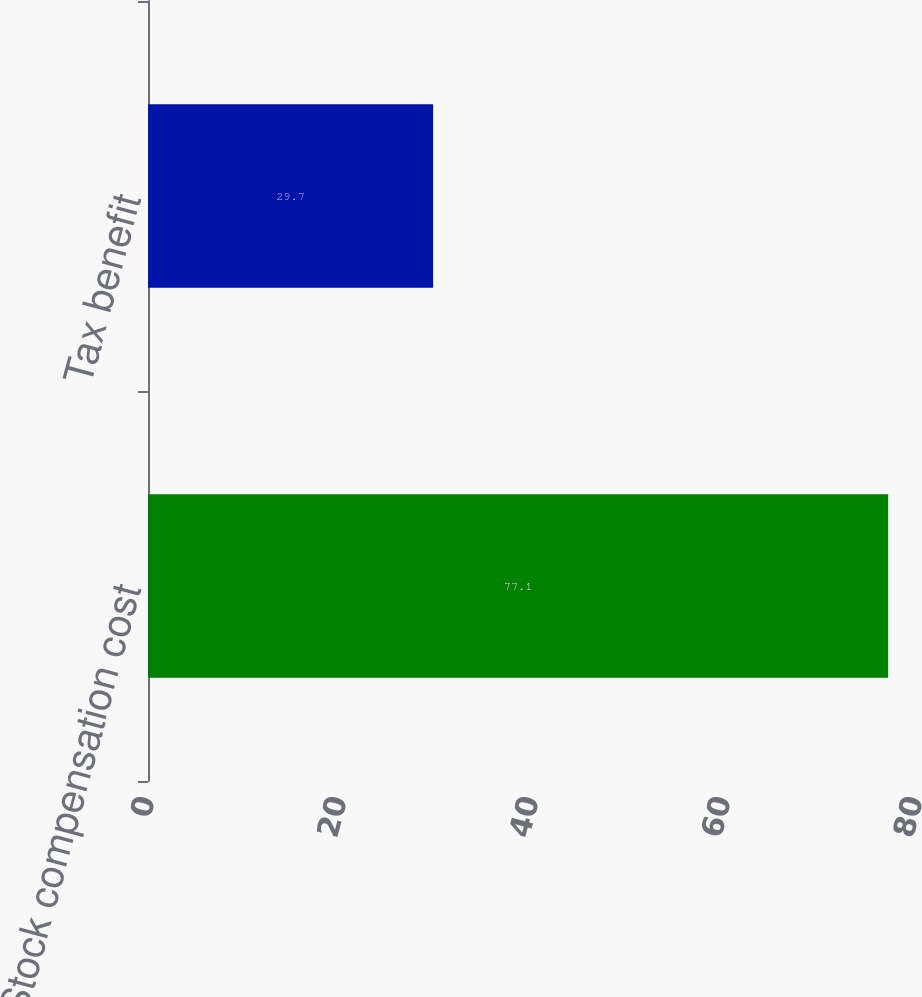Convert chart. <chart><loc_0><loc_0><loc_500><loc_500><bar_chart><fcel>Stock compensation cost<fcel>Tax benefit<nl><fcel>77.1<fcel>29.7<nl></chart> 